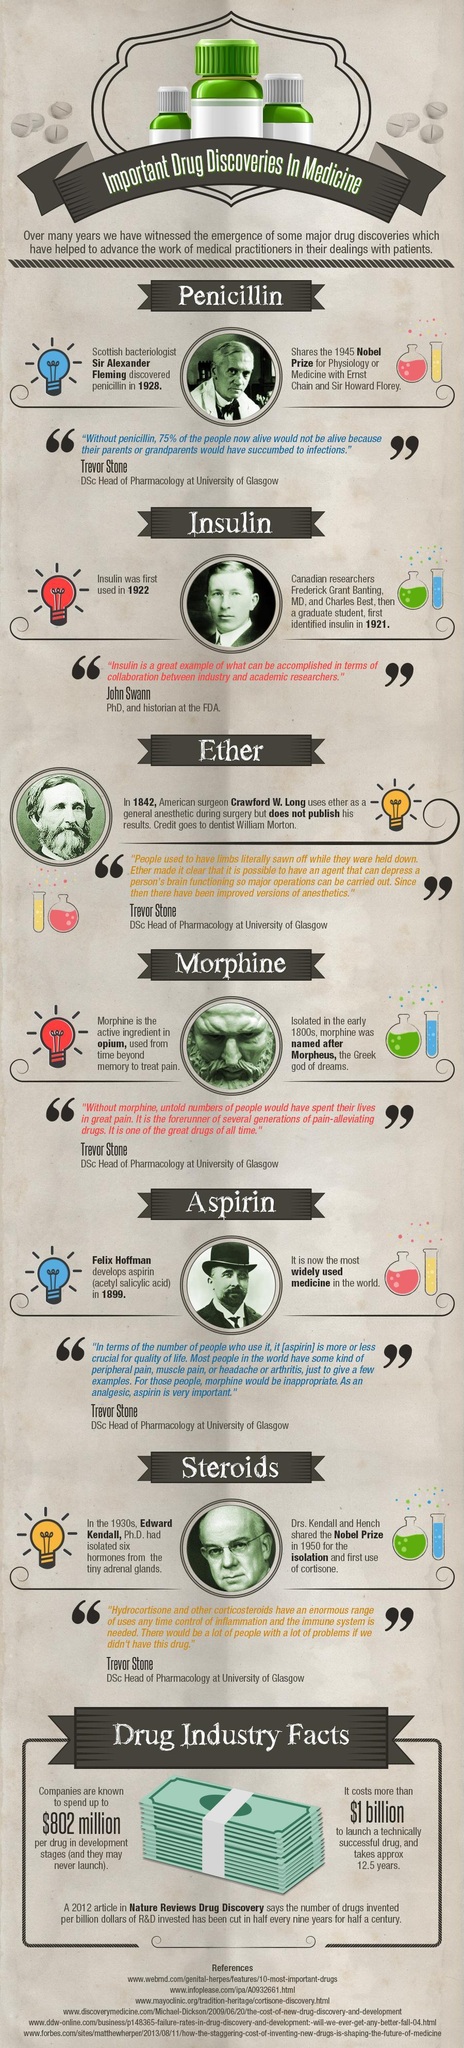How many red bulbs are in this infographic?
Answer the question with a short phrase. 2 How many test tubes are in this infographic? 6 How many blue bulbs are in this infographic? 2 How many drugs mentioned in this infographic? 6 